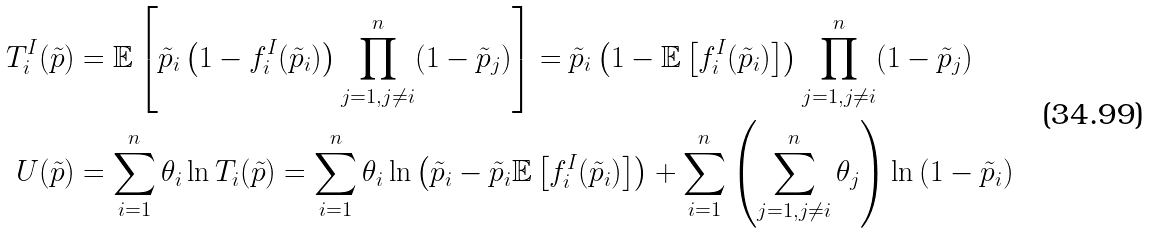<formula> <loc_0><loc_0><loc_500><loc_500>T _ { i } ^ { I } ( \tilde { p } ) & = \mathbb { E } \left [ \tilde { p } _ { i } \left ( 1 - f _ { i } ^ { I } ( \tilde { p } _ { i } ) \right ) \prod _ { j = 1 , j \neq i } ^ { n } ( 1 - \tilde { p } _ { j } ) \right ] = \tilde { p } _ { i } \left ( 1 - \mathbb { E } \left [ f _ { i } ^ { I } ( \tilde { p } _ { i } ) \right ] \right ) \prod _ { j = 1 , j \neq i } ^ { n } ( 1 - \tilde { p } _ { j } ) \\ U ( \tilde { p } ) & = \sum _ { i = 1 } ^ { n } \theta _ { i } \ln T _ { i } ( \tilde { p } ) = \sum _ { i = 1 } ^ { n } \theta _ { i } \ln \left ( \tilde { p } _ { i } - \tilde { p } _ { i } \mathbb { E } \left [ f _ { i } ^ { I } ( \tilde { p } _ { i } ) \right ] \right ) + \sum _ { i = 1 } ^ { n } \left ( \sum _ { j = 1 , j \neq i } ^ { n } \theta _ { j } \right ) \ln \left ( 1 - \tilde { p } _ { i } \right )</formula> 